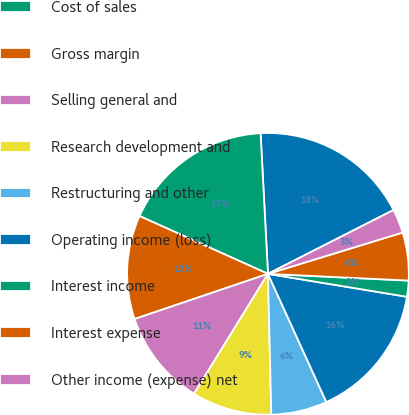Convert chart to OTSL. <chart><loc_0><loc_0><loc_500><loc_500><pie_chart><fcel>Net sales<fcel>Cost of sales<fcel>Gross margin<fcel>Selling general and<fcel>Research development and<fcel>Restructuring and other<fcel>Operating income (loss)<fcel>Interest income<fcel>Interest expense<fcel>Other income (expense) net<nl><fcel>18.35%<fcel>17.43%<fcel>11.93%<fcel>11.01%<fcel>9.17%<fcel>6.42%<fcel>15.6%<fcel>1.84%<fcel>5.5%<fcel>2.75%<nl></chart> 